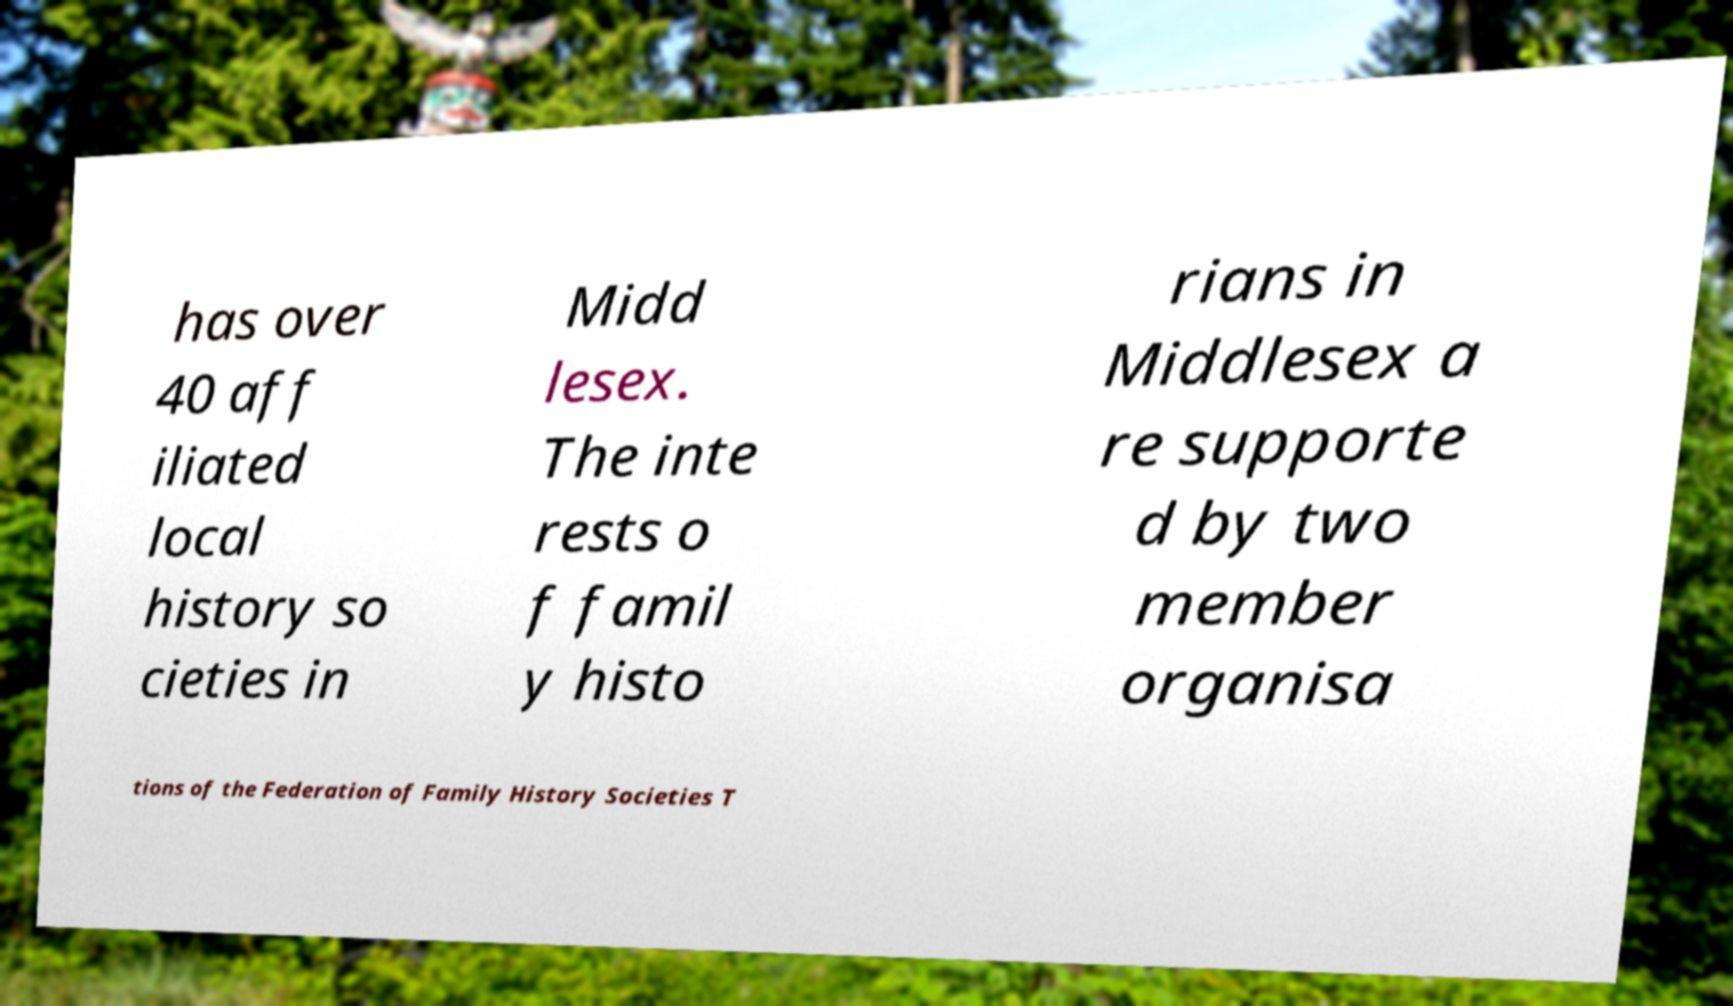Can you accurately transcribe the text from the provided image for me? has over 40 aff iliated local history so cieties in Midd lesex. The inte rests o f famil y histo rians in Middlesex a re supporte d by two member organisa tions of the Federation of Family History Societies T 